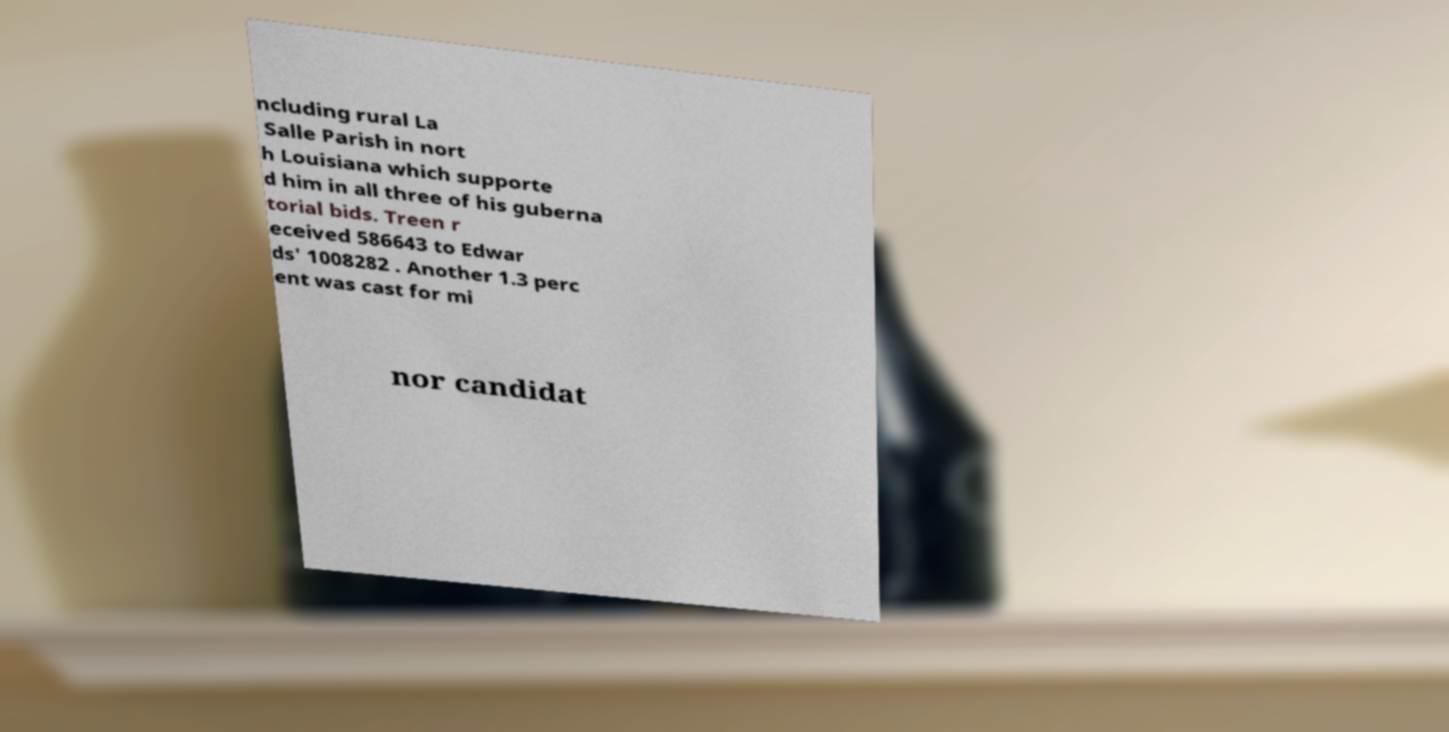Please identify and transcribe the text found in this image. ncluding rural La Salle Parish in nort h Louisiana which supporte d him in all three of his guberna torial bids. Treen r eceived 586643 to Edwar ds' 1008282 . Another 1.3 perc ent was cast for mi nor candidat 